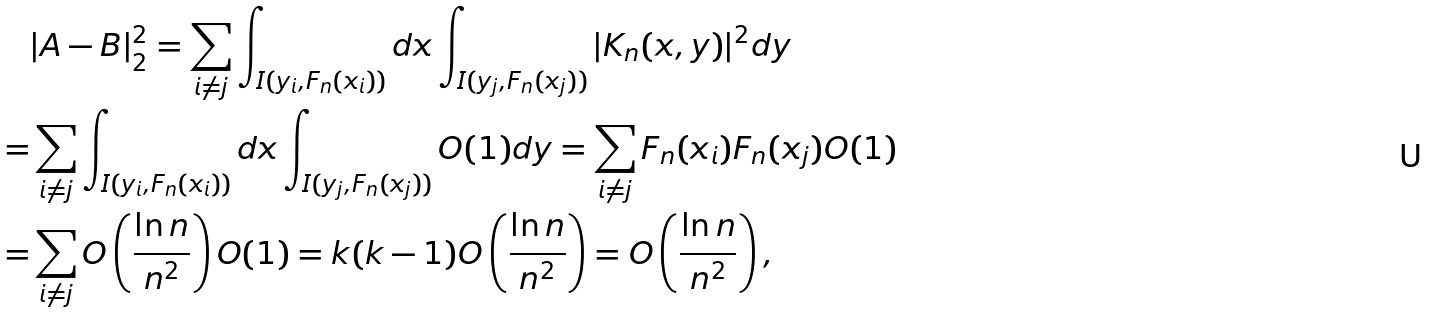<formula> <loc_0><loc_0><loc_500><loc_500>& | A - B | _ { 2 } ^ { 2 } = \sum _ { i \neq j } \int _ { I ( y _ { i } , F _ { n } ( x _ { i } ) ) } d x \int _ { I ( y _ { j } , F _ { n } ( x _ { j } ) ) } | K _ { n } ( x , y ) | ^ { 2 } d y \\ = & \sum _ { i \neq j } \int _ { I ( y _ { i } , F _ { n } ( x _ { i } ) ) } d x \int _ { I ( y _ { j } , F _ { n } ( x _ { j } ) ) } O ( 1 ) d y = \sum _ { i \neq j } F _ { n } ( x _ { i } ) F _ { n } ( x _ { j } ) O ( 1 ) \\ = & \sum _ { i \neq j } O \left ( \frac { \ln n } { n ^ { 2 } } \right ) O ( 1 ) = k ( k - 1 ) O \left ( \frac { \ln n } { n ^ { 2 } } \right ) = O \left ( \frac { \ln n } { n ^ { 2 } } \right ) ,</formula> 